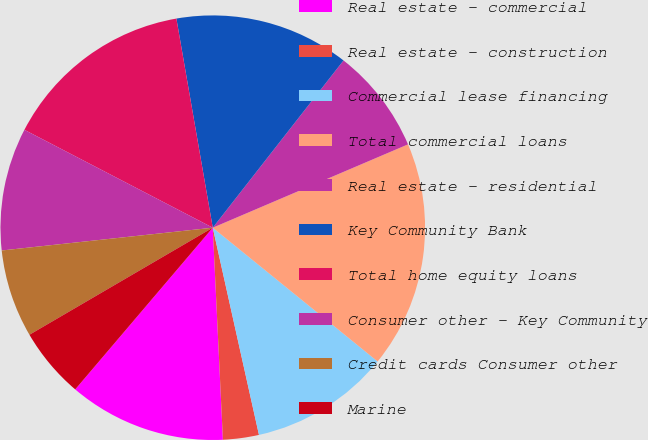Convert chart to OTSL. <chart><loc_0><loc_0><loc_500><loc_500><pie_chart><fcel>Real estate - commercial<fcel>Real estate - construction<fcel>Commercial lease financing<fcel>Total commercial loans<fcel>Real estate - residential<fcel>Key Community Bank<fcel>Total home equity loans<fcel>Consumer other - Key Community<fcel>Credit cards Consumer other<fcel>Marine<nl><fcel>11.98%<fcel>2.73%<fcel>10.66%<fcel>17.27%<fcel>8.02%<fcel>13.3%<fcel>14.63%<fcel>9.34%<fcel>6.7%<fcel>5.37%<nl></chart> 